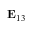Convert formula to latex. <formula><loc_0><loc_0><loc_500><loc_500>E _ { 1 3 }</formula> 